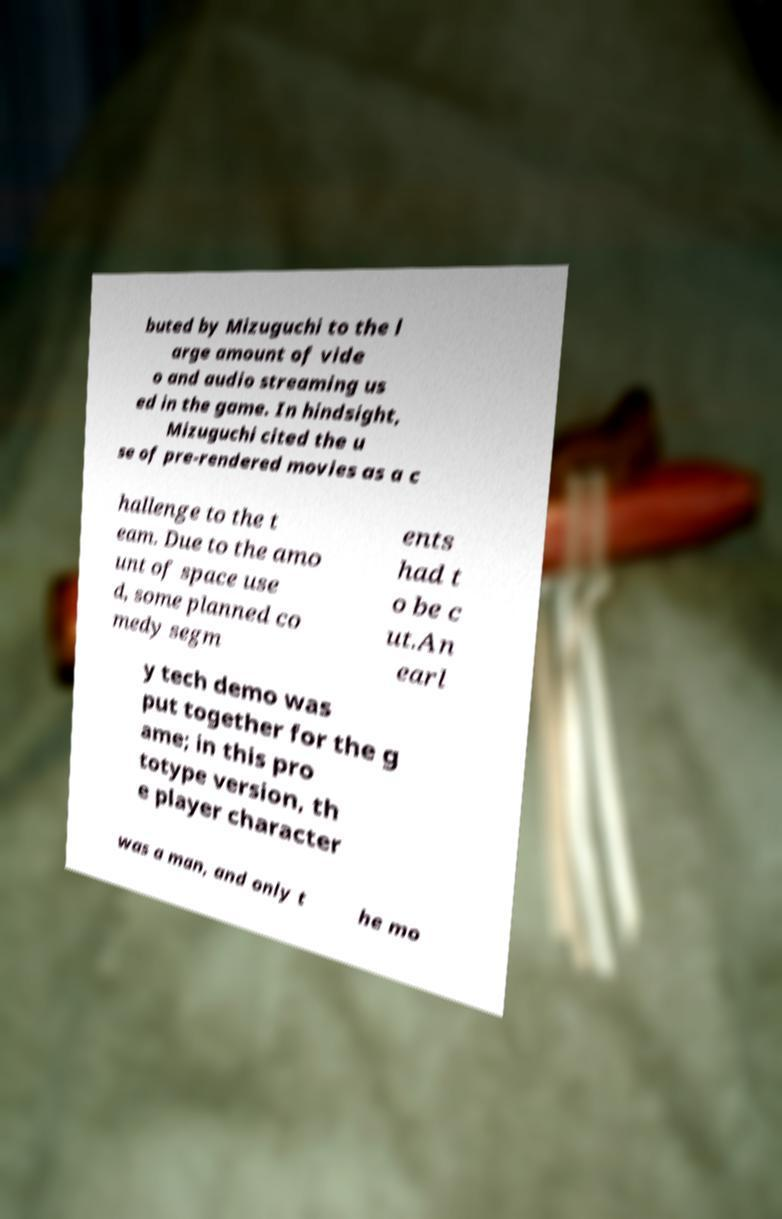For documentation purposes, I need the text within this image transcribed. Could you provide that? buted by Mizuguchi to the l arge amount of vide o and audio streaming us ed in the game. In hindsight, Mizuguchi cited the u se of pre-rendered movies as a c hallenge to the t eam. Due to the amo unt of space use d, some planned co medy segm ents had t o be c ut.An earl y tech demo was put together for the g ame; in this pro totype version, th e player character was a man, and only t he mo 